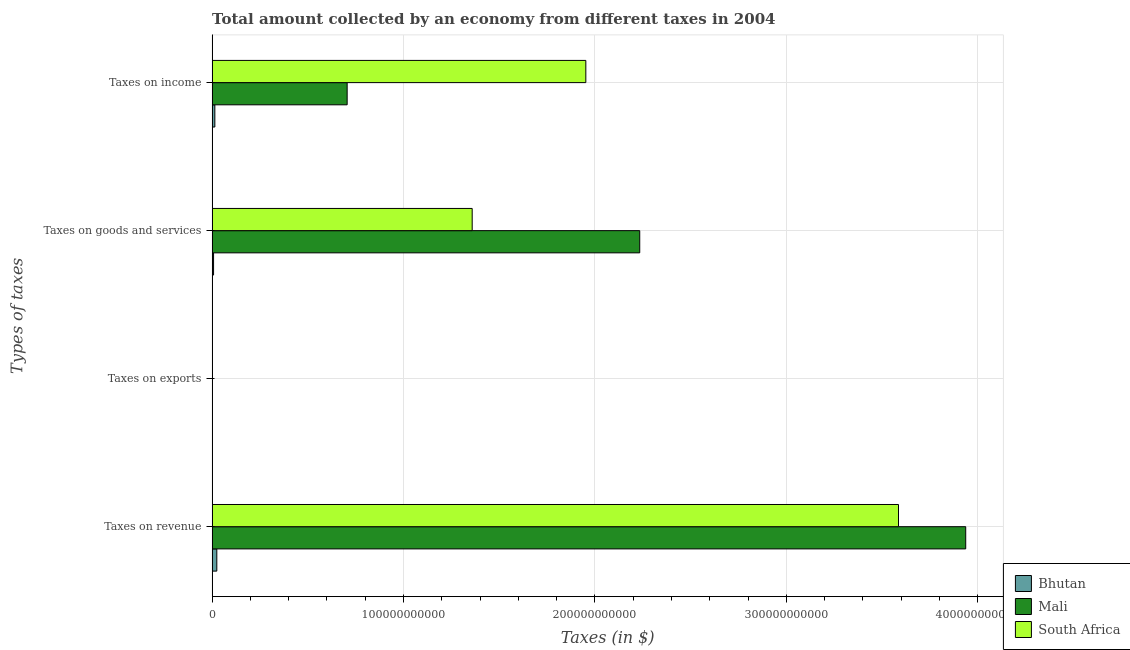How many different coloured bars are there?
Your answer should be very brief. 3. What is the label of the 4th group of bars from the top?
Offer a terse response. Taxes on revenue. What is the amount collected as tax on income in Mali?
Your answer should be very brief. 7.05e+1. Across all countries, what is the maximum amount collected as tax on exports?
Ensure brevity in your answer.  4.41e+06. Across all countries, what is the minimum amount collected as tax on exports?
Offer a very short reply. 4.91e+05. In which country was the amount collected as tax on goods maximum?
Offer a terse response. Mali. In which country was the amount collected as tax on exports minimum?
Give a very brief answer. Bhutan. What is the total amount collected as tax on goods in the graph?
Your response must be concise. 3.60e+11. What is the difference between the amount collected as tax on goods in Bhutan and that in Mali?
Give a very brief answer. -2.23e+11. What is the difference between the amount collected as tax on revenue in Bhutan and the amount collected as tax on exports in South Africa?
Offer a very short reply. 2.45e+09. What is the average amount collected as tax on revenue per country?
Provide a succinct answer. 2.52e+11. What is the difference between the amount collected as tax on income and amount collected as tax on exports in South Africa?
Ensure brevity in your answer.  1.95e+11. In how many countries, is the amount collected as tax on exports greater than 180000000000 $?
Ensure brevity in your answer.  0. What is the ratio of the amount collected as tax on revenue in South Africa to that in Bhutan?
Provide a succinct answer. 146.55. Is the amount collected as tax on goods in Mali less than that in South Africa?
Make the answer very short. No. What is the difference between the highest and the second highest amount collected as tax on exports?
Give a very brief answer. 3.41e+06. What is the difference between the highest and the lowest amount collected as tax on goods?
Keep it short and to the point. 2.23e+11. What does the 1st bar from the top in Taxes on revenue represents?
Your response must be concise. South Africa. What does the 2nd bar from the bottom in Taxes on revenue represents?
Give a very brief answer. Mali. Are all the bars in the graph horizontal?
Make the answer very short. Yes. How many countries are there in the graph?
Your answer should be compact. 3. What is the difference between two consecutive major ticks on the X-axis?
Your answer should be compact. 1.00e+11. Does the graph contain any zero values?
Offer a very short reply. No. Does the graph contain grids?
Your answer should be very brief. Yes. What is the title of the graph?
Your answer should be very brief. Total amount collected by an economy from different taxes in 2004. What is the label or title of the X-axis?
Make the answer very short. Taxes (in $). What is the label or title of the Y-axis?
Make the answer very short. Types of taxes. What is the Taxes (in $) of Bhutan in Taxes on revenue?
Give a very brief answer. 2.45e+09. What is the Taxes (in $) in Mali in Taxes on revenue?
Provide a succinct answer. 3.94e+11. What is the Taxes (in $) in South Africa in Taxes on revenue?
Provide a short and direct response. 3.59e+11. What is the Taxes (in $) of Bhutan in Taxes on exports?
Keep it short and to the point. 4.91e+05. What is the Taxes (in $) of Mali in Taxes on exports?
Your response must be concise. 4.41e+06. What is the Taxes (in $) of South Africa in Taxes on exports?
Your response must be concise. 1.00e+06. What is the Taxes (in $) of Bhutan in Taxes on goods and services?
Ensure brevity in your answer.  7.50e+08. What is the Taxes (in $) of Mali in Taxes on goods and services?
Offer a terse response. 2.23e+11. What is the Taxes (in $) of South Africa in Taxes on goods and services?
Keep it short and to the point. 1.36e+11. What is the Taxes (in $) of Bhutan in Taxes on income?
Ensure brevity in your answer.  1.42e+09. What is the Taxes (in $) in Mali in Taxes on income?
Your response must be concise. 7.05e+1. What is the Taxes (in $) in South Africa in Taxes on income?
Your response must be concise. 1.95e+11. Across all Types of taxes, what is the maximum Taxes (in $) of Bhutan?
Make the answer very short. 2.45e+09. Across all Types of taxes, what is the maximum Taxes (in $) of Mali?
Provide a succinct answer. 3.94e+11. Across all Types of taxes, what is the maximum Taxes (in $) in South Africa?
Offer a terse response. 3.59e+11. Across all Types of taxes, what is the minimum Taxes (in $) of Bhutan?
Offer a very short reply. 4.91e+05. Across all Types of taxes, what is the minimum Taxes (in $) in Mali?
Make the answer very short. 4.41e+06. What is the total Taxes (in $) in Bhutan in the graph?
Your answer should be very brief. 4.62e+09. What is the total Taxes (in $) of Mali in the graph?
Offer a terse response. 6.88e+11. What is the total Taxes (in $) in South Africa in the graph?
Your answer should be very brief. 6.90e+11. What is the difference between the Taxes (in $) of Bhutan in Taxes on revenue and that in Taxes on exports?
Keep it short and to the point. 2.45e+09. What is the difference between the Taxes (in $) in Mali in Taxes on revenue and that in Taxes on exports?
Offer a very short reply. 3.94e+11. What is the difference between the Taxes (in $) of South Africa in Taxes on revenue and that in Taxes on exports?
Your response must be concise. 3.59e+11. What is the difference between the Taxes (in $) in Bhutan in Taxes on revenue and that in Taxes on goods and services?
Offer a very short reply. 1.70e+09. What is the difference between the Taxes (in $) in Mali in Taxes on revenue and that in Taxes on goods and services?
Offer a terse response. 1.70e+11. What is the difference between the Taxes (in $) of South Africa in Taxes on revenue and that in Taxes on goods and services?
Make the answer very short. 2.23e+11. What is the difference between the Taxes (in $) in Bhutan in Taxes on revenue and that in Taxes on income?
Offer a terse response. 1.03e+09. What is the difference between the Taxes (in $) of Mali in Taxes on revenue and that in Taxes on income?
Provide a short and direct response. 3.23e+11. What is the difference between the Taxes (in $) in South Africa in Taxes on revenue and that in Taxes on income?
Your answer should be very brief. 1.63e+11. What is the difference between the Taxes (in $) of Bhutan in Taxes on exports and that in Taxes on goods and services?
Keep it short and to the point. -7.50e+08. What is the difference between the Taxes (in $) of Mali in Taxes on exports and that in Taxes on goods and services?
Your response must be concise. -2.23e+11. What is the difference between the Taxes (in $) in South Africa in Taxes on exports and that in Taxes on goods and services?
Give a very brief answer. -1.36e+11. What is the difference between the Taxes (in $) of Bhutan in Taxes on exports and that in Taxes on income?
Your response must be concise. -1.42e+09. What is the difference between the Taxes (in $) in Mali in Taxes on exports and that in Taxes on income?
Ensure brevity in your answer.  -7.05e+1. What is the difference between the Taxes (in $) in South Africa in Taxes on exports and that in Taxes on income?
Provide a succinct answer. -1.95e+11. What is the difference between the Taxes (in $) of Bhutan in Taxes on goods and services and that in Taxes on income?
Offer a very short reply. -6.69e+08. What is the difference between the Taxes (in $) of Mali in Taxes on goods and services and that in Taxes on income?
Offer a very short reply. 1.53e+11. What is the difference between the Taxes (in $) of South Africa in Taxes on goods and services and that in Taxes on income?
Your response must be concise. -5.94e+1. What is the difference between the Taxes (in $) in Bhutan in Taxes on revenue and the Taxes (in $) in Mali in Taxes on exports?
Your response must be concise. 2.44e+09. What is the difference between the Taxes (in $) in Bhutan in Taxes on revenue and the Taxes (in $) in South Africa in Taxes on exports?
Provide a short and direct response. 2.45e+09. What is the difference between the Taxes (in $) of Mali in Taxes on revenue and the Taxes (in $) of South Africa in Taxes on exports?
Keep it short and to the point. 3.94e+11. What is the difference between the Taxes (in $) in Bhutan in Taxes on revenue and the Taxes (in $) in Mali in Taxes on goods and services?
Offer a very short reply. -2.21e+11. What is the difference between the Taxes (in $) of Bhutan in Taxes on revenue and the Taxes (in $) of South Africa in Taxes on goods and services?
Offer a terse response. -1.33e+11. What is the difference between the Taxes (in $) of Mali in Taxes on revenue and the Taxes (in $) of South Africa in Taxes on goods and services?
Give a very brief answer. 2.58e+11. What is the difference between the Taxes (in $) in Bhutan in Taxes on revenue and the Taxes (in $) in Mali in Taxes on income?
Your answer should be very brief. -6.81e+1. What is the difference between the Taxes (in $) of Bhutan in Taxes on revenue and the Taxes (in $) of South Africa in Taxes on income?
Your response must be concise. -1.93e+11. What is the difference between the Taxes (in $) of Mali in Taxes on revenue and the Taxes (in $) of South Africa in Taxes on income?
Your answer should be very brief. 1.98e+11. What is the difference between the Taxes (in $) of Bhutan in Taxes on exports and the Taxes (in $) of Mali in Taxes on goods and services?
Keep it short and to the point. -2.23e+11. What is the difference between the Taxes (in $) of Bhutan in Taxes on exports and the Taxes (in $) of South Africa in Taxes on goods and services?
Your answer should be compact. -1.36e+11. What is the difference between the Taxes (in $) of Mali in Taxes on exports and the Taxes (in $) of South Africa in Taxes on goods and services?
Provide a short and direct response. -1.36e+11. What is the difference between the Taxes (in $) in Bhutan in Taxes on exports and the Taxes (in $) in Mali in Taxes on income?
Provide a succinct answer. -7.05e+1. What is the difference between the Taxes (in $) in Bhutan in Taxes on exports and the Taxes (in $) in South Africa in Taxes on income?
Provide a short and direct response. -1.95e+11. What is the difference between the Taxes (in $) in Mali in Taxes on exports and the Taxes (in $) in South Africa in Taxes on income?
Provide a succinct answer. -1.95e+11. What is the difference between the Taxes (in $) of Bhutan in Taxes on goods and services and the Taxes (in $) of Mali in Taxes on income?
Make the answer very short. -6.98e+1. What is the difference between the Taxes (in $) of Bhutan in Taxes on goods and services and the Taxes (in $) of South Africa in Taxes on income?
Offer a terse response. -1.94e+11. What is the difference between the Taxes (in $) in Mali in Taxes on goods and services and the Taxes (in $) in South Africa in Taxes on income?
Your response must be concise. 2.82e+1. What is the average Taxes (in $) of Bhutan per Types of taxes?
Ensure brevity in your answer.  1.15e+09. What is the average Taxes (in $) of Mali per Types of taxes?
Your answer should be compact. 1.72e+11. What is the average Taxes (in $) in South Africa per Types of taxes?
Offer a terse response. 1.72e+11. What is the difference between the Taxes (in $) of Bhutan and Taxes (in $) of Mali in Taxes on revenue?
Offer a very short reply. -3.91e+11. What is the difference between the Taxes (in $) in Bhutan and Taxes (in $) in South Africa in Taxes on revenue?
Your answer should be very brief. -3.56e+11. What is the difference between the Taxes (in $) of Mali and Taxes (in $) of South Africa in Taxes on revenue?
Ensure brevity in your answer.  3.51e+1. What is the difference between the Taxes (in $) in Bhutan and Taxes (in $) in Mali in Taxes on exports?
Provide a short and direct response. -3.92e+06. What is the difference between the Taxes (in $) of Bhutan and Taxes (in $) of South Africa in Taxes on exports?
Provide a short and direct response. -5.09e+05. What is the difference between the Taxes (in $) of Mali and Taxes (in $) of South Africa in Taxes on exports?
Make the answer very short. 3.41e+06. What is the difference between the Taxes (in $) in Bhutan and Taxes (in $) in Mali in Taxes on goods and services?
Keep it short and to the point. -2.23e+11. What is the difference between the Taxes (in $) in Bhutan and Taxes (in $) in South Africa in Taxes on goods and services?
Offer a terse response. -1.35e+11. What is the difference between the Taxes (in $) of Mali and Taxes (in $) of South Africa in Taxes on goods and services?
Your answer should be very brief. 8.75e+1. What is the difference between the Taxes (in $) in Bhutan and Taxes (in $) in Mali in Taxes on income?
Make the answer very short. -6.91e+1. What is the difference between the Taxes (in $) of Bhutan and Taxes (in $) of South Africa in Taxes on income?
Provide a short and direct response. -1.94e+11. What is the difference between the Taxes (in $) in Mali and Taxes (in $) in South Africa in Taxes on income?
Make the answer very short. -1.25e+11. What is the ratio of the Taxes (in $) in Bhutan in Taxes on revenue to that in Taxes on exports?
Keep it short and to the point. 4982.89. What is the ratio of the Taxes (in $) of Mali in Taxes on revenue to that in Taxes on exports?
Provide a succinct answer. 8.92e+04. What is the ratio of the Taxes (in $) in South Africa in Taxes on revenue to that in Taxes on exports?
Offer a terse response. 3.59e+05. What is the ratio of the Taxes (in $) in Bhutan in Taxes on revenue to that in Taxes on goods and services?
Make the answer very short. 3.26. What is the ratio of the Taxes (in $) of Mali in Taxes on revenue to that in Taxes on goods and services?
Provide a succinct answer. 1.76. What is the ratio of the Taxes (in $) in South Africa in Taxes on revenue to that in Taxes on goods and services?
Ensure brevity in your answer.  2.64. What is the ratio of the Taxes (in $) of Bhutan in Taxes on revenue to that in Taxes on income?
Keep it short and to the point. 1.72. What is the ratio of the Taxes (in $) in Mali in Taxes on revenue to that in Taxes on income?
Keep it short and to the point. 5.58. What is the ratio of the Taxes (in $) in South Africa in Taxes on revenue to that in Taxes on income?
Your answer should be very brief. 1.84. What is the ratio of the Taxes (in $) of Bhutan in Taxes on exports to that in Taxes on goods and services?
Give a very brief answer. 0. What is the ratio of the Taxes (in $) in Mali in Taxes on exports to that in Taxes on goods and services?
Your response must be concise. 0. What is the ratio of the Taxes (in $) in Bhutan in Taxes on exports to that in Taxes on income?
Your answer should be compact. 0. What is the ratio of the Taxes (in $) in South Africa in Taxes on exports to that in Taxes on income?
Your answer should be compact. 0. What is the ratio of the Taxes (in $) in Bhutan in Taxes on goods and services to that in Taxes on income?
Your answer should be compact. 0.53. What is the ratio of the Taxes (in $) of Mali in Taxes on goods and services to that in Taxes on income?
Make the answer very short. 3.17. What is the ratio of the Taxes (in $) of South Africa in Taxes on goods and services to that in Taxes on income?
Your response must be concise. 0.7. What is the difference between the highest and the second highest Taxes (in $) of Bhutan?
Keep it short and to the point. 1.03e+09. What is the difference between the highest and the second highest Taxes (in $) of Mali?
Your answer should be compact. 1.70e+11. What is the difference between the highest and the second highest Taxes (in $) of South Africa?
Provide a succinct answer. 1.63e+11. What is the difference between the highest and the lowest Taxes (in $) in Bhutan?
Give a very brief answer. 2.45e+09. What is the difference between the highest and the lowest Taxes (in $) in Mali?
Your response must be concise. 3.94e+11. What is the difference between the highest and the lowest Taxes (in $) of South Africa?
Offer a terse response. 3.59e+11. 